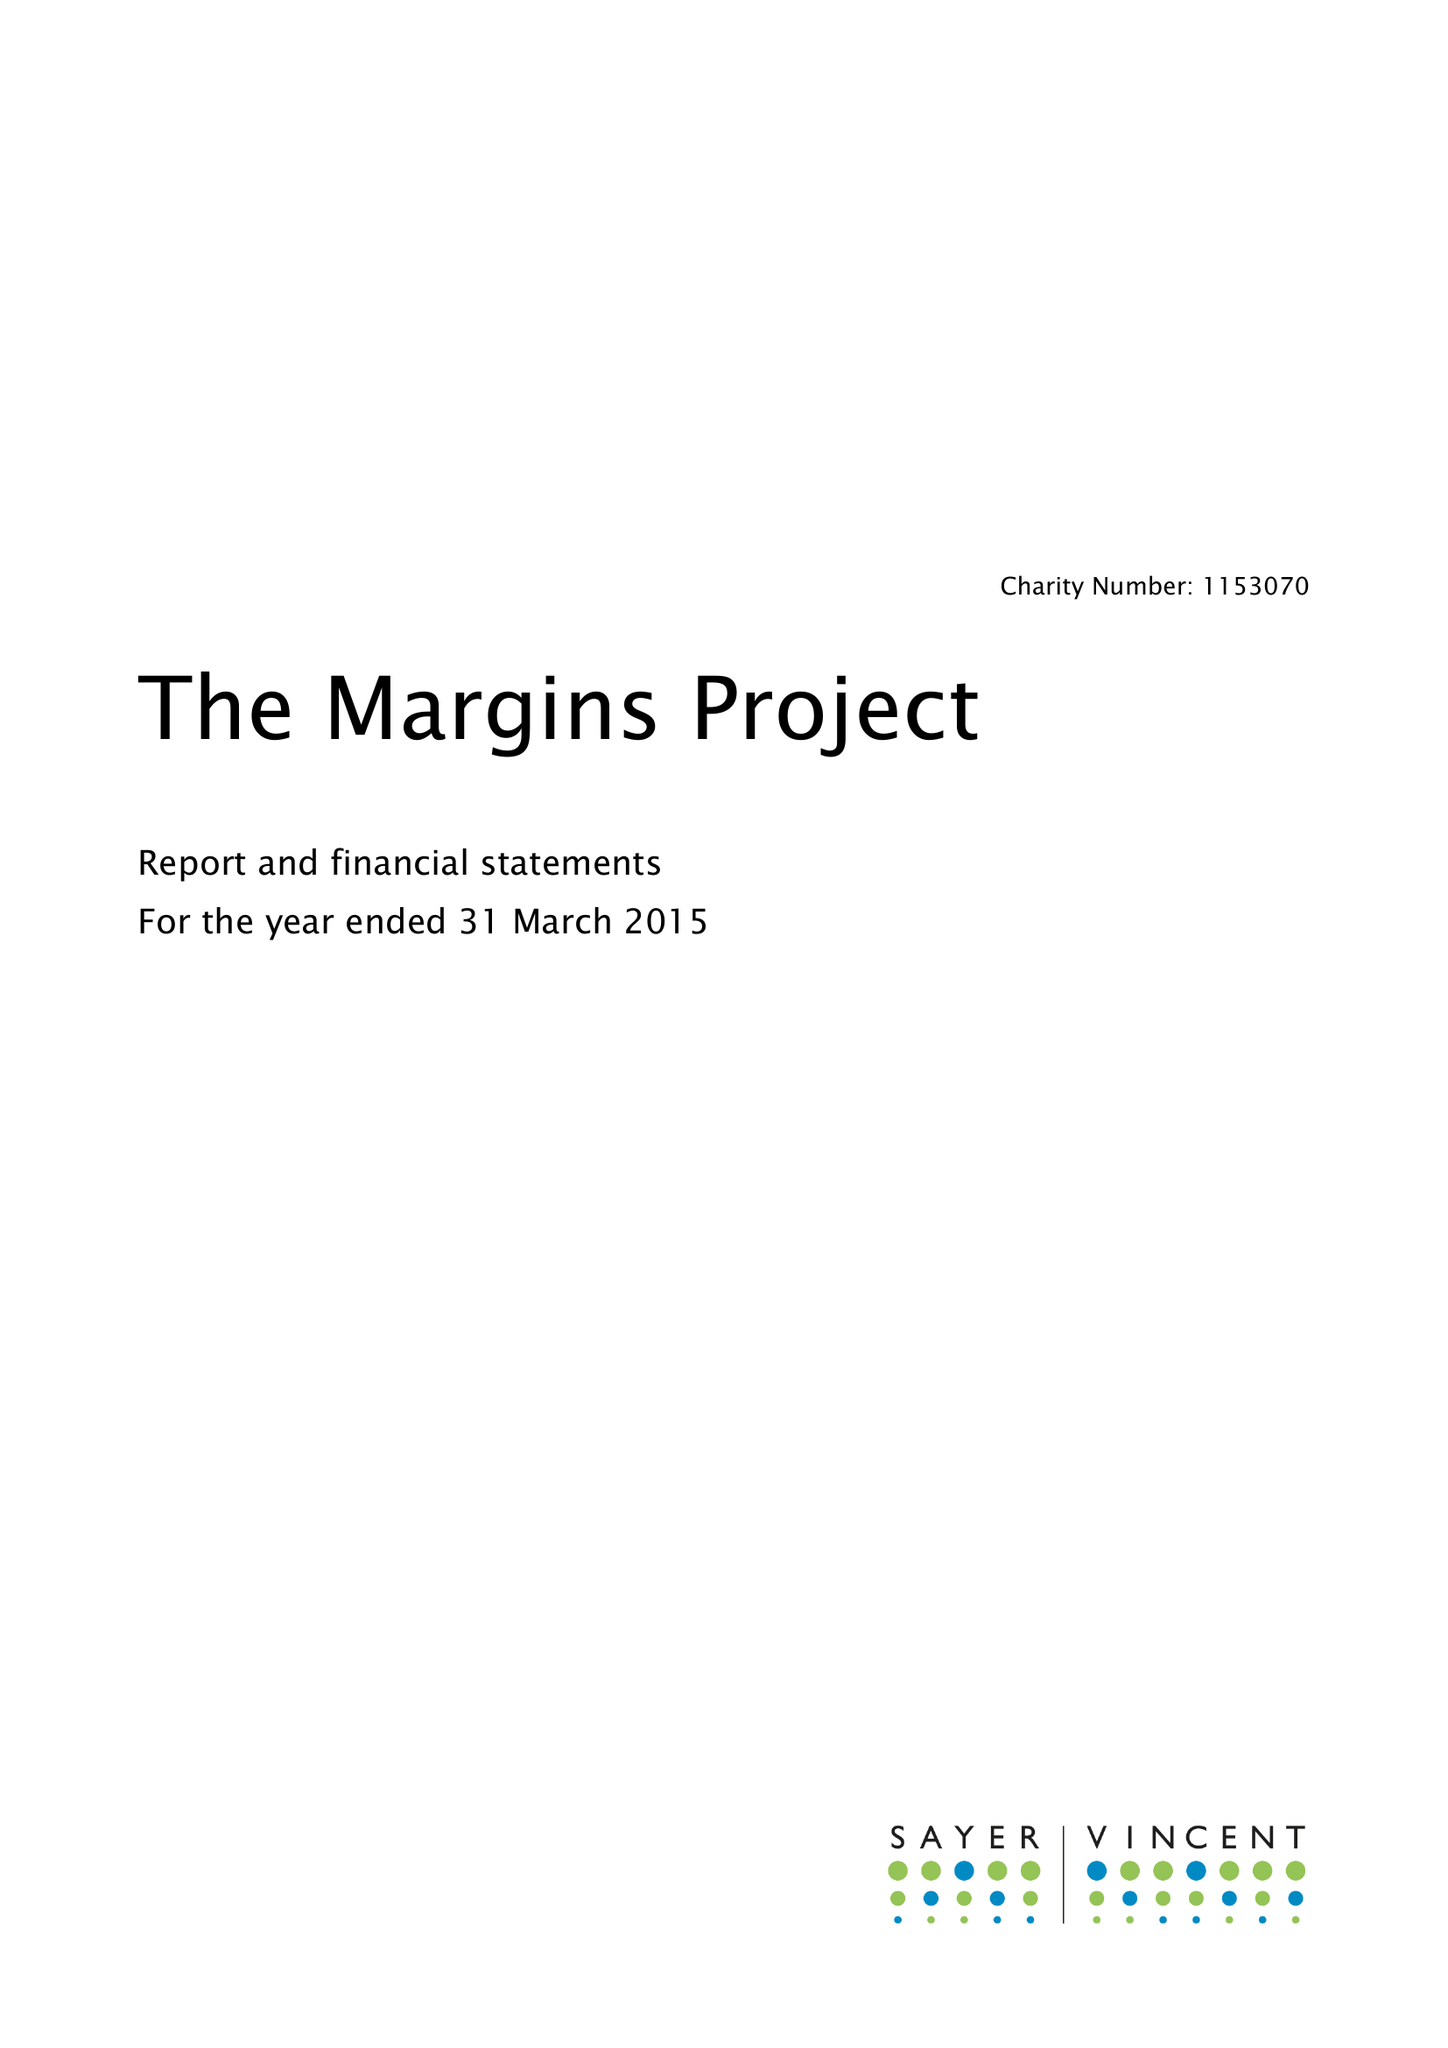What is the value for the address__postcode?
Answer the question using a single word or phrase. N1 2UN 